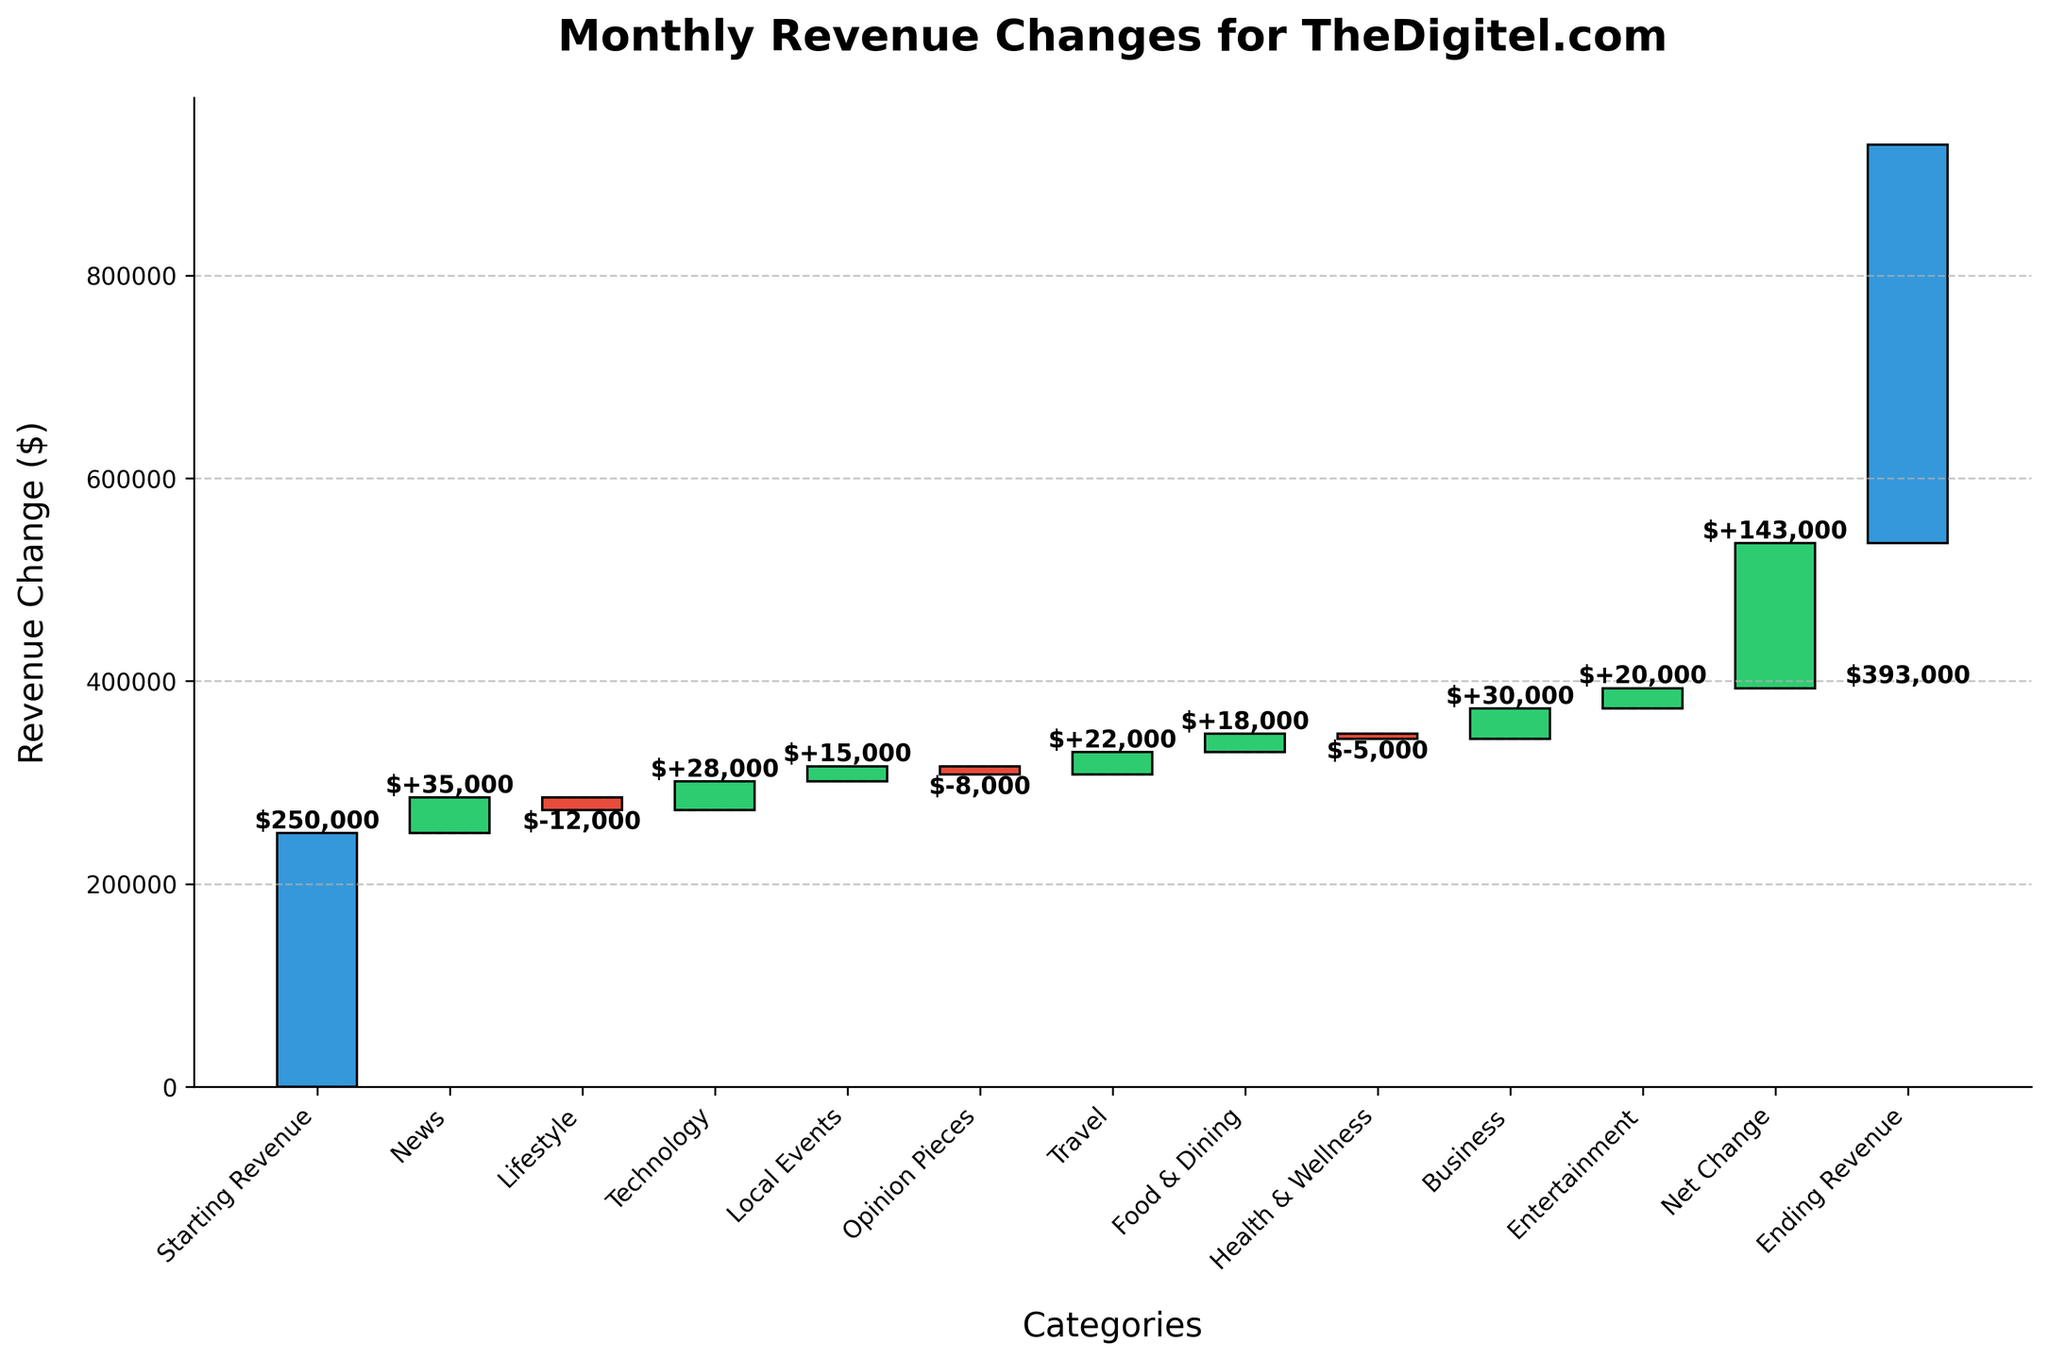What is the title of the figure? The title of the figure is located at the top and often describes the overall content or purpose of the chart.
Answer: Monthly Revenue Changes for TheDigitel.com What are the categories listed on the x-axis? The categories on the x-axis are the specific segments for which the revenue changes are tracked. They can be read directly from the labels at the bottom of each bar.
Answer: Starting Revenue, News, Lifestyle, Technology, Local Events, Opinion Pieces, Travel, Food & Dining, Health & Wellness, Business, Entertainment, Net Change, Ending Revenue Which category has the highest positive revenue change? By comparing the height of the bars representing gains, the category with the highest positive change is noticeable.
Answer: Business Which category has the highest negative revenue change? By comparing the height of the bars representing losses, we can determine the one with the largest drop.
Answer: Lifestyle How much is the net change in revenue? The net change is explicitly labeled on the chart and represents the cumulative change from the starting revenue to the ending revenue.
Answer: 143,000 What is the difference in revenue change between Technology and Lifestyle? The revenue change for Technology is +28,000 and for Lifestyle is -12,000. Subtract the two values to find the difference.
Answer: 40,000 How many categories show a negative revenue change? Count the bars displayed in red color to determine the number of categories with a negative change.
Answer: 3 What is the total revenue increase contributed by positive categories? Sum the positive revenue changes derived from News, Technology, Local Events, Travel, Food & Dining, Business, and Entertainment.
Answer: 151,000 How much revenue do News and Business contribute to the total revenue change combined? Add the individual contributions from News (+35,000) and Business (+30,000) to find the combined revenue contribution.
Answer: 65,000 How does the revenue change for Local Events compare to that of Food & Dining? Compare the heights of their respective bars; since both categories see a positive change, directly compare their values.
Answer: Local Events: 15,000, Food & Dining: 18,000 